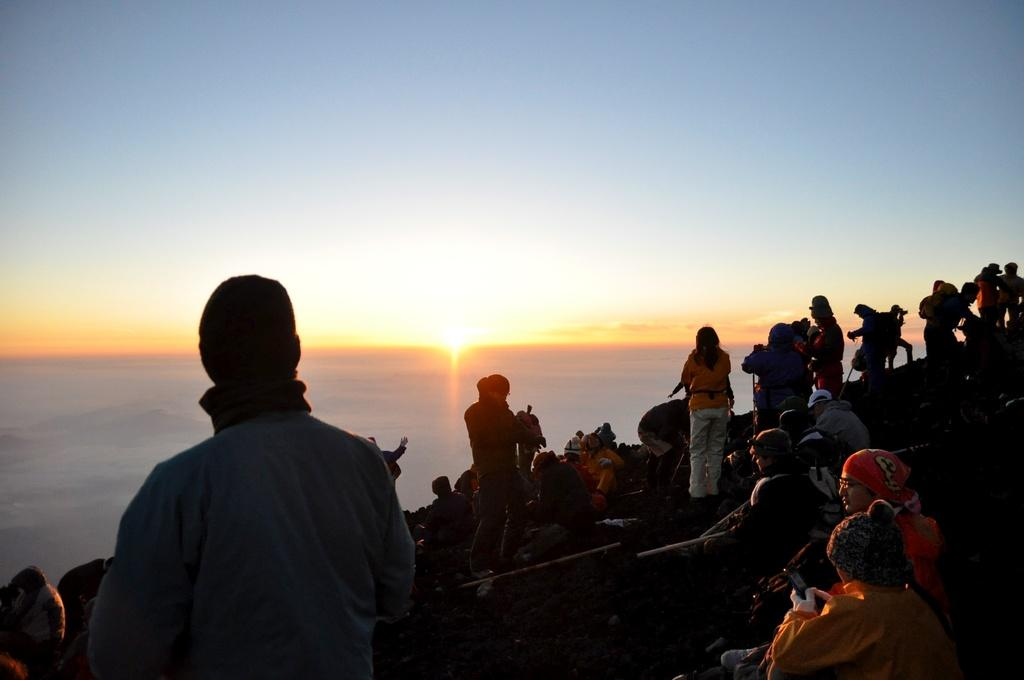What is happening on the sloppy land in the image? There are people sitting and standing on the sloppy land in the image. What can be seen in the background of the image? The background of the image includes the sun. What else is visible in the background of the image? The sky is visible in the background of the image. What purpose does the sheet serve in the image? There is no sheet present in the image. 